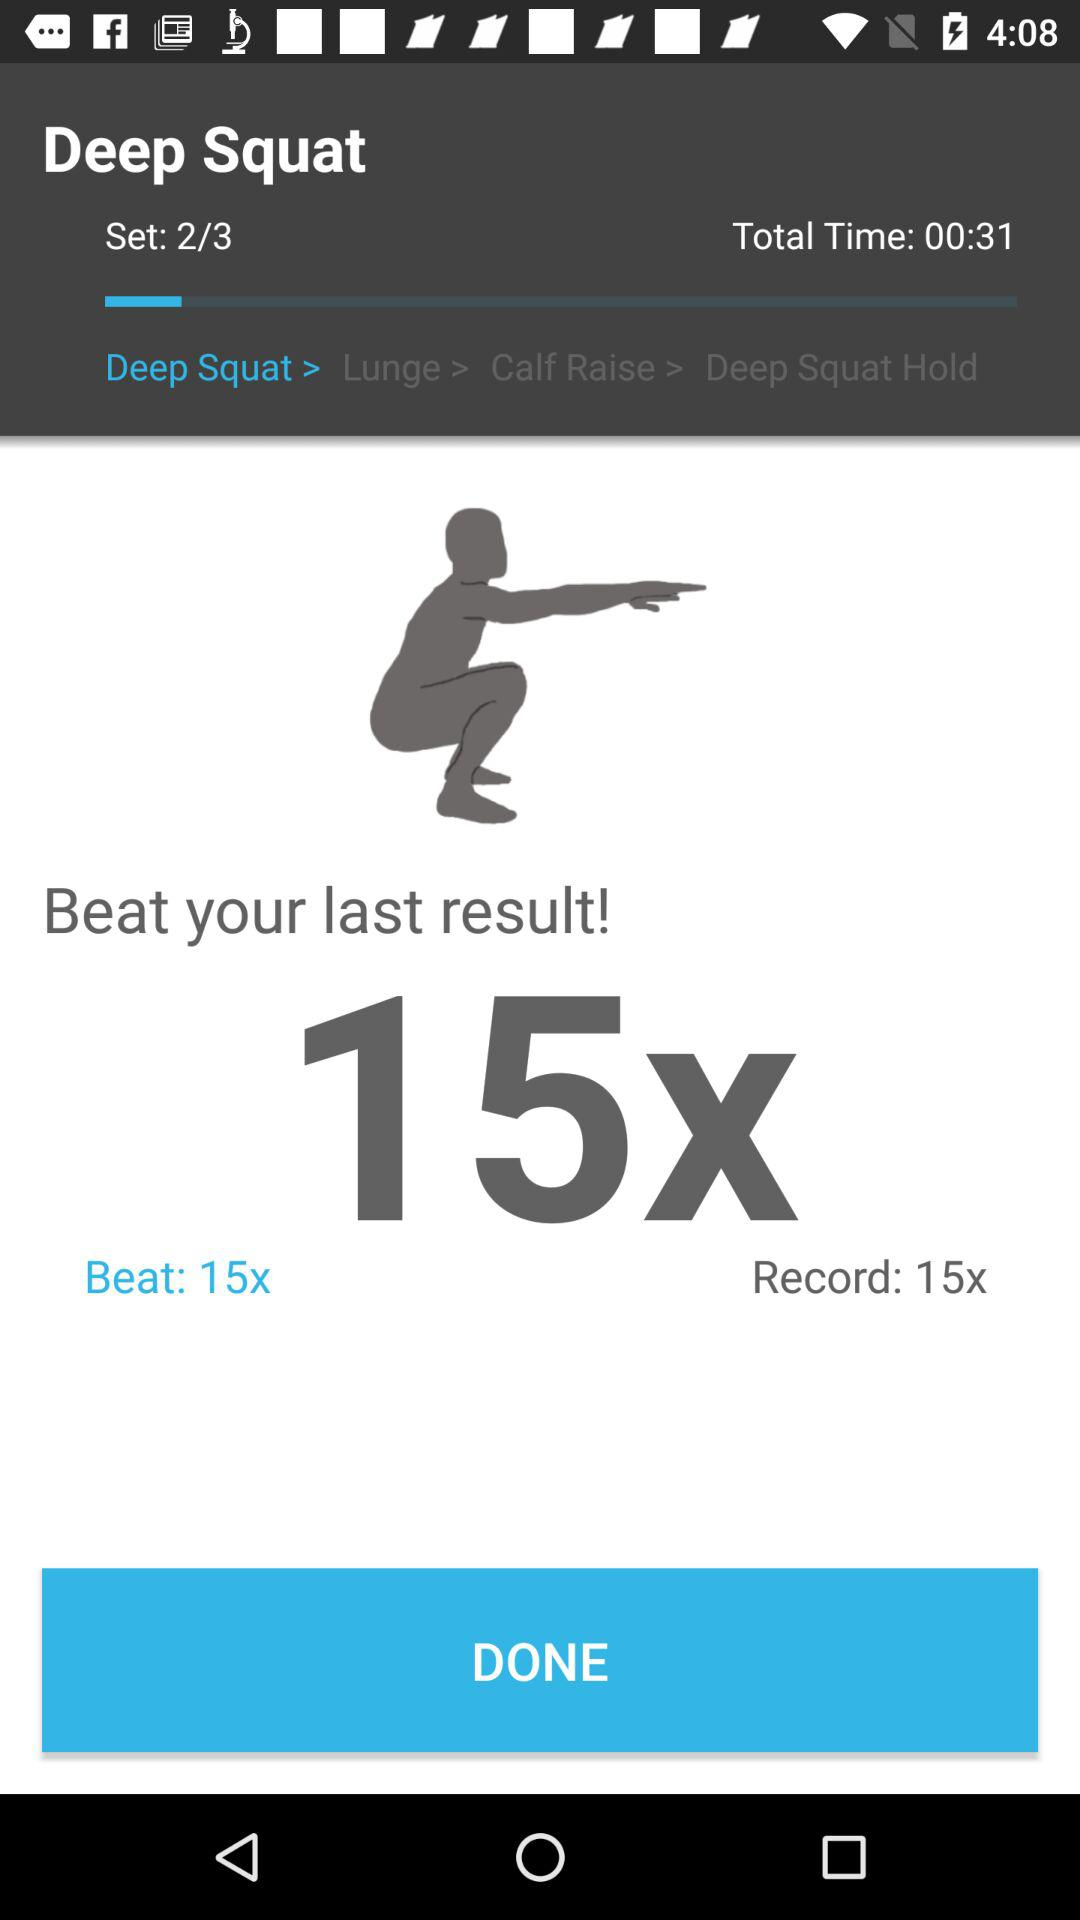How many reps are in the record?
Answer the question using a single word or phrase. 15 